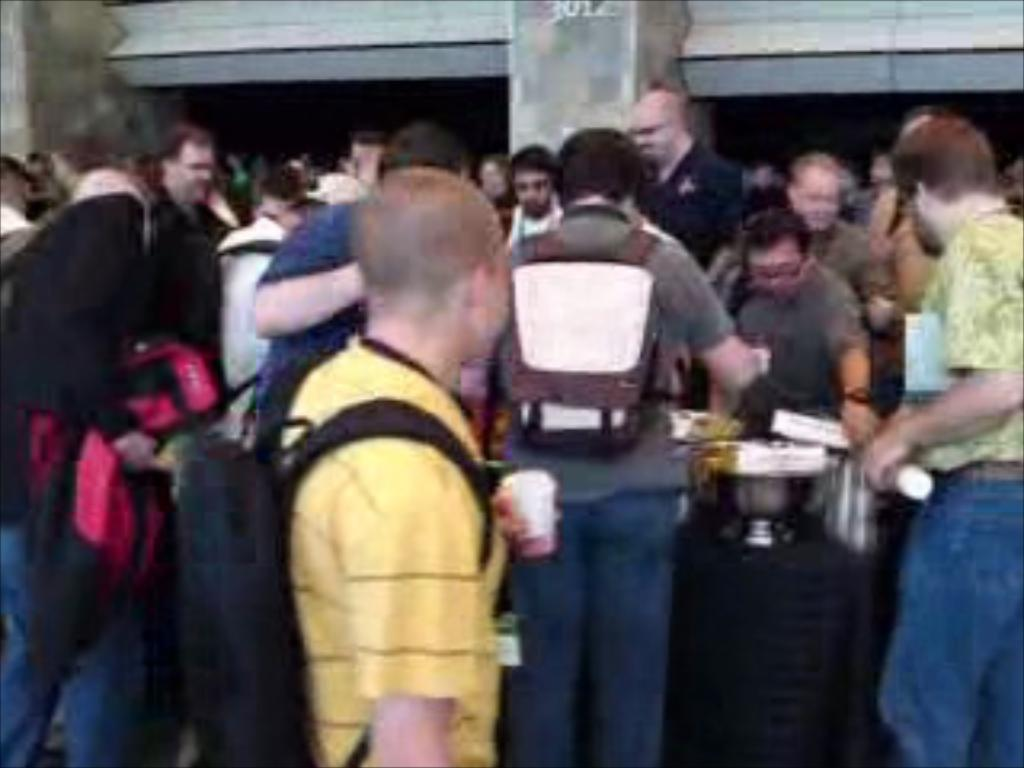How many people are standing around the table in the image? There are few persons standing around a table in the image. What can be seen on the table in the image? There are objects placed on the table in the image. What type of drug is being used by the persons in the image? There is no indication of any drug use in the image; the persons are simply standing around a table. How many steps can be seen leading up to the table in the image? There is no mention of any steps leading up to the table in the image. 